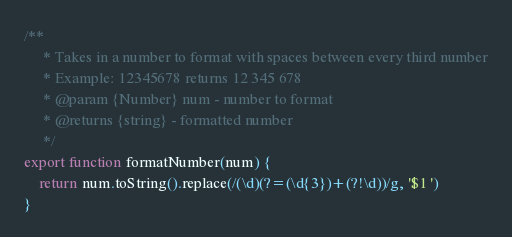Convert code to text. <code><loc_0><loc_0><loc_500><loc_500><_JavaScript_>/**
     * Takes in a number to format with spaces between every third number
     * Example: 12345678 returns 12 345 678
     * @param {Number} num - number to format
     * @returns {string} - formatted number
     */
export function formatNumber(num) {
    return num.toString().replace(/(\d)(?=(\d{3})+(?!\d))/g, '$1 ')
}
</code> 